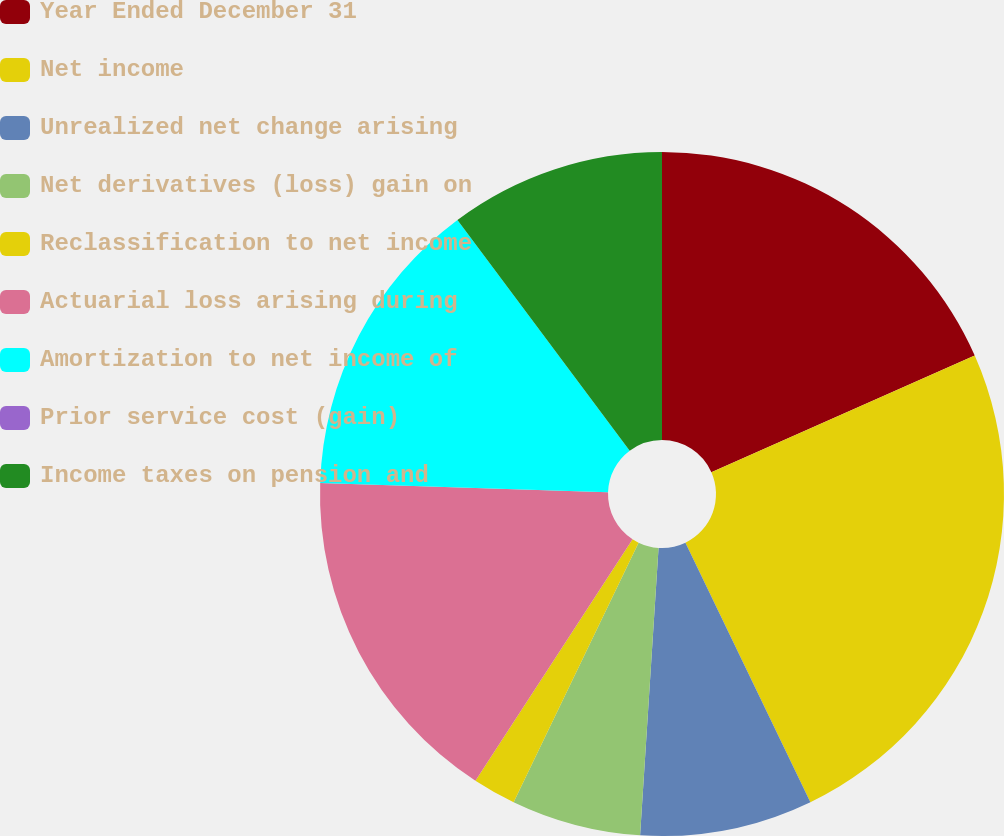<chart> <loc_0><loc_0><loc_500><loc_500><pie_chart><fcel>Year Ended December 31<fcel>Net income<fcel>Unrealized net change arising<fcel>Net derivatives (loss) gain on<fcel>Reclassification to net income<fcel>Actuarial loss arising during<fcel>Amortization to net income of<fcel>Prior service cost (gain)<fcel>Income taxes on pension and<nl><fcel>18.36%<fcel>24.48%<fcel>8.16%<fcel>6.12%<fcel>2.04%<fcel>16.32%<fcel>14.28%<fcel>0.0%<fcel>10.2%<nl></chart> 